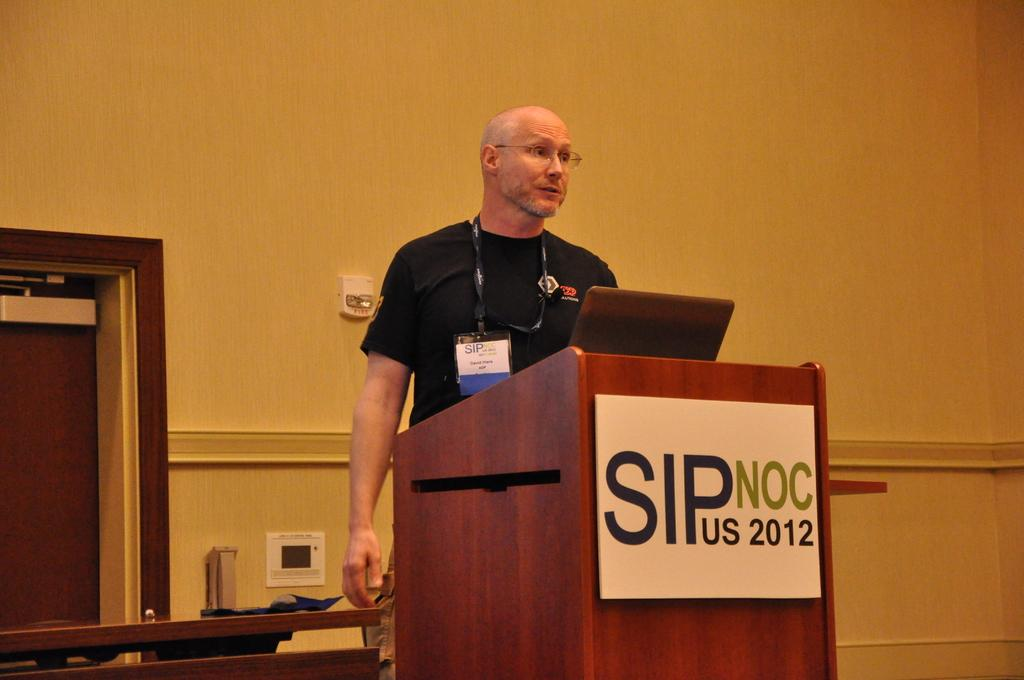What is the main subject of the image? The main subject of the image is a man standing. Can you describe the man's appearance? The man is wearing clothes and spectacles. Does the man have any identification in the image? Yes, the man has an identity card. What is the setting of the image? There is a podium, a door, a wall, and a poster in the image. What type of cup is the man holding in the image? There is no cup present in the image. Can you describe the magic trick the man is performing in the image? There is no magic trick being performed in the image; the man is simply standing with an identity card. 